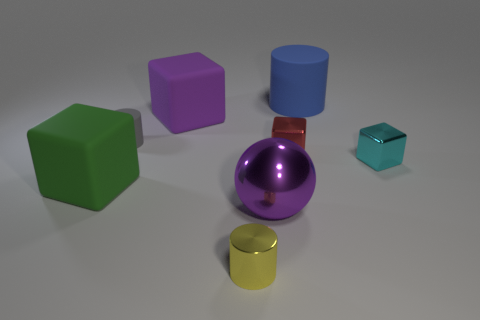Is the number of gray things that are to the right of the tiny yellow shiny cylinder the same as the number of large cylinders that are in front of the small red block?
Provide a short and direct response. Yes. Is the number of purple rubber blocks that are left of the purple matte thing greater than the number of large green rubber cubes?
Your answer should be compact. No. What number of things are tiny metallic cubes that are behind the tiny cyan block or yellow rubber cubes?
Give a very brief answer. 1. How many tiny cylinders are made of the same material as the small red thing?
Make the answer very short. 1. There is a rubber object that is the same color as the ball; what is its shape?
Offer a terse response. Cube. Are there any small green rubber things that have the same shape as the cyan shiny object?
Your answer should be very brief. No. The yellow thing that is the same size as the red metal thing is what shape?
Ensure brevity in your answer.  Cylinder. Do the big cylinder and the big shiny ball to the right of the big green rubber cube have the same color?
Provide a succinct answer. No. There is a rubber cylinder that is left of the big ball; what number of purple spheres are left of it?
Give a very brief answer. 0. There is a cylinder that is both behind the yellow cylinder and in front of the big cylinder; what is its size?
Your answer should be compact. Small. 